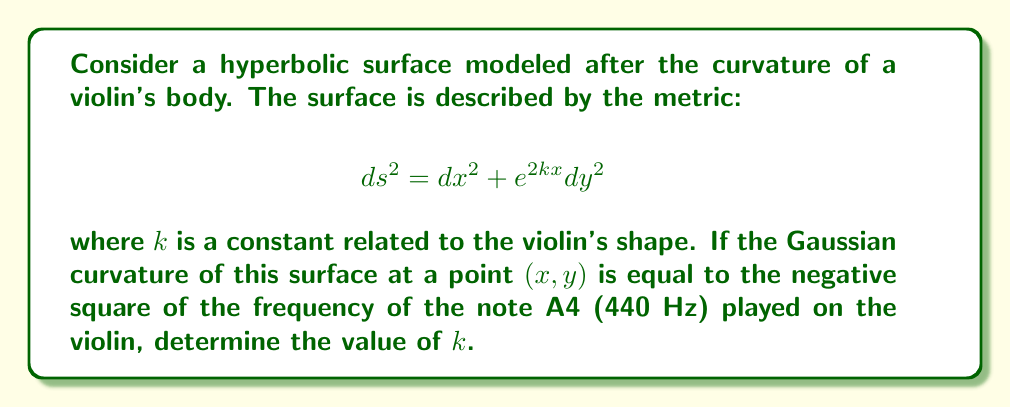Could you help me with this problem? Let's approach this step-by-step:

1) For a surface with metric $ds^2 = E dx^2 + 2F dx dy + G dy^2$, the Gaussian curvature $K$ is given by:

   $$K = -\frac{1}{2\sqrt{EG-F^2}}\left(\frac{\partial}{\partial x}\left(\frac{G_x}{\sqrt{EG-F^2}}\right) + \frac{\partial}{\partial y}\left(\frac{E_y}{\sqrt{EG-F^2}}\right)\right)$$

2) In our case, $E=1$, $F=0$, and $G=e^{2kx}$. So, $\sqrt{EG-F^2} = e^{kx}$.

3) We need to calculate $G_x$ and $E_y$:
   $G_x = \frac{\partial}{\partial x}(e^{2kx}) = 2ke^{2kx}$
   $E_y = \frac{\partial}{\partial y}(1) = 0$

4) Substituting into the curvature formula:

   $$K = -\frac{1}{2e^{kx}}\left(\frac{\partial}{\partial x}\left(\frac{2ke^{2kx}}{e^{kx}}\right) + \frac{\partial}{\partial y}(0)\right)$$

5) Simplifying:

   $$K = -\frac{1}{2e^{kx}}\frac{\partial}{\partial x}(2ke^{kx}) = -\frac{1}{2e^{kx}}(2k^2e^{kx}) = -k^2$$

6) We're told that this curvature is equal to the negative square of the frequency of A4:

   $$-k^2 = -(440)^2$$

7) Solving for $k$:

   $$k^2 = 440^2$$
   $$k = 440$$ (taking the positive root as $k$ is described as a constant)
Answer: $k = 440$ 